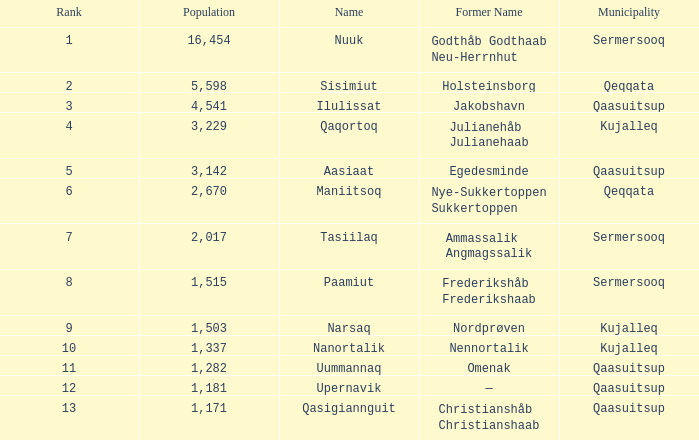What is the population for Rank 11? 1282.0. 